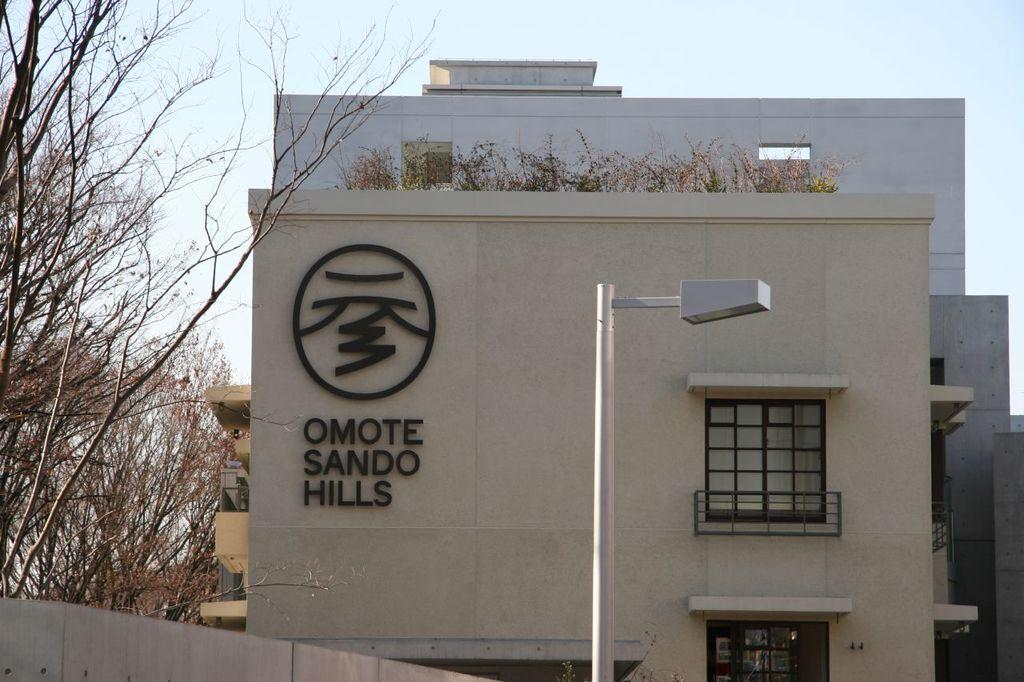What structure can be seen in the image? There is a street light pole in the image. What type of vegetation is present in the image? There are trees in the image. What is the color of the building in the image? The building in the image is cream in color. What else can be seen in the background of the image? There are other buildings visible in the background of the image. What is visible in the sky in the image? The sky is visible in the background of the image. What type of cloth is draped over the street light pole in the image? There is no cloth draped over the street light pole in the image. Is there any sleet visible in the image? There is no mention of sleet in the provided facts, and it is not visible in the image. 